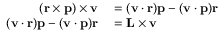<formula> <loc_0><loc_0><loc_500><loc_500>\begin{array} { r l } { ( r \times p ) \times v } & = ( v \cdot r ) p - ( v \cdot p ) r } \\ { ( v \cdot r ) p - ( v \cdot p ) r } & = L \times v } \end{array}</formula> 